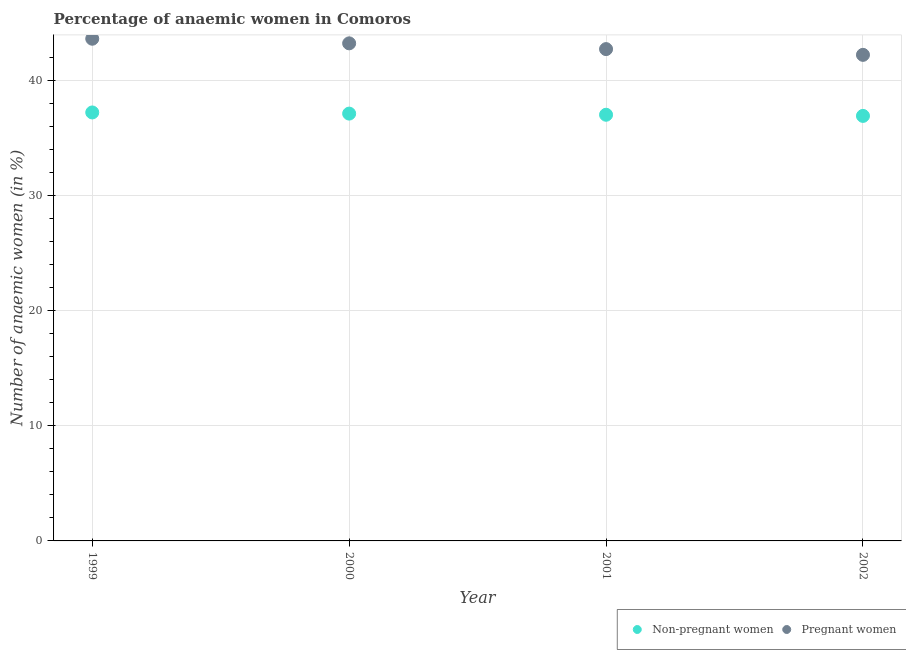How many different coloured dotlines are there?
Provide a succinct answer. 2. Is the number of dotlines equal to the number of legend labels?
Ensure brevity in your answer.  Yes. What is the percentage of non-pregnant anaemic women in 2000?
Offer a very short reply. 37.1. Across all years, what is the maximum percentage of non-pregnant anaemic women?
Ensure brevity in your answer.  37.2. Across all years, what is the minimum percentage of pregnant anaemic women?
Provide a short and direct response. 42.2. What is the total percentage of non-pregnant anaemic women in the graph?
Provide a short and direct response. 148.2. What is the difference between the percentage of non-pregnant anaemic women in 1999 and that in 2001?
Give a very brief answer. 0.2. What is the difference between the percentage of non-pregnant anaemic women in 2001 and the percentage of pregnant anaemic women in 2000?
Offer a terse response. -6.2. What is the average percentage of pregnant anaemic women per year?
Provide a short and direct response. 42.92. In the year 1999, what is the difference between the percentage of pregnant anaemic women and percentage of non-pregnant anaemic women?
Your response must be concise. 6.4. In how many years, is the percentage of pregnant anaemic women greater than 18 %?
Your answer should be compact. 4. What is the ratio of the percentage of pregnant anaemic women in 1999 to that in 2000?
Your response must be concise. 1.01. What is the difference between the highest and the second highest percentage of non-pregnant anaemic women?
Offer a very short reply. 0.1. What is the difference between the highest and the lowest percentage of non-pregnant anaemic women?
Your response must be concise. 0.3. In how many years, is the percentage of non-pregnant anaemic women greater than the average percentage of non-pregnant anaemic women taken over all years?
Ensure brevity in your answer.  2. Is the percentage of pregnant anaemic women strictly less than the percentage of non-pregnant anaemic women over the years?
Provide a succinct answer. No. What is the difference between two consecutive major ticks on the Y-axis?
Keep it short and to the point. 10. Does the graph contain any zero values?
Ensure brevity in your answer.  No. Where does the legend appear in the graph?
Keep it short and to the point. Bottom right. What is the title of the graph?
Your answer should be very brief. Percentage of anaemic women in Comoros. What is the label or title of the Y-axis?
Provide a short and direct response. Number of anaemic women (in %). What is the Number of anaemic women (in %) in Non-pregnant women in 1999?
Make the answer very short. 37.2. What is the Number of anaemic women (in %) of Pregnant women in 1999?
Ensure brevity in your answer.  43.6. What is the Number of anaemic women (in %) in Non-pregnant women in 2000?
Give a very brief answer. 37.1. What is the Number of anaemic women (in %) in Pregnant women in 2000?
Provide a short and direct response. 43.2. What is the Number of anaemic women (in %) in Non-pregnant women in 2001?
Provide a short and direct response. 37. What is the Number of anaemic women (in %) in Pregnant women in 2001?
Make the answer very short. 42.7. What is the Number of anaemic women (in %) of Non-pregnant women in 2002?
Your response must be concise. 36.9. What is the Number of anaemic women (in %) in Pregnant women in 2002?
Provide a short and direct response. 42.2. Across all years, what is the maximum Number of anaemic women (in %) in Non-pregnant women?
Make the answer very short. 37.2. Across all years, what is the maximum Number of anaemic women (in %) of Pregnant women?
Provide a succinct answer. 43.6. Across all years, what is the minimum Number of anaemic women (in %) of Non-pregnant women?
Ensure brevity in your answer.  36.9. Across all years, what is the minimum Number of anaemic women (in %) in Pregnant women?
Ensure brevity in your answer.  42.2. What is the total Number of anaemic women (in %) in Non-pregnant women in the graph?
Your answer should be very brief. 148.2. What is the total Number of anaemic women (in %) in Pregnant women in the graph?
Your response must be concise. 171.7. What is the difference between the Number of anaemic women (in %) of Non-pregnant women in 1999 and that in 2000?
Make the answer very short. 0.1. What is the difference between the Number of anaemic women (in %) of Non-pregnant women in 1999 and that in 2001?
Ensure brevity in your answer.  0.2. What is the difference between the Number of anaemic women (in %) in Pregnant women in 1999 and that in 2001?
Provide a succinct answer. 0.9. What is the difference between the Number of anaemic women (in %) in Non-pregnant women in 1999 and that in 2002?
Provide a succinct answer. 0.3. What is the difference between the Number of anaemic women (in %) of Pregnant women in 1999 and that in 2002?
Ensure brevity in your answer.  1.4. What is the difference between the Number of anaemic women (in %) in Non-pregnant women in 2000 and that in 2001?
Offer a very short reply. 0.1. What is the difference between the Number of anaemic women (in %) of Pregnant women in 2000 and that in 2001?
Give a very brief answer. 0.5. What is the difference between the Number of anaemic women (in %) in Non-pregnant women in 2001 and that in 2002?
Ensure brevity in your answer.  0.1. What is the difference between the Number of anaemic women (in %) in Pregnant women in 2001 and that in 2002?
Ensure brevity in your answer.  0.5. What is the difference between the Number of anaemic women (in %) in Non-pregnant women in 2001 and the Number of anaemic women (in %) in Pregnant women in 2002?
Keep it short and to the point. -5.2. What is the average Number of anaemic women (in %) of Non-pregnant women per year?
Offer a very short reply. 37.05. What is the average Number of anaemic women (in %) in Pregnant women per year?
Provide a succinct answer. 42.92. In the year 1999, what is the difference between the Number of anaemic women (in %) of Non-pregnant women and Number of anaemic women (in %) of Pregnant women?
Your answer should be very brief. -6.4. In the year 2000, what is the difference between the Number of anaemic women (in %) of Non-pregnant women and Number of anaemic women (in %) of Pregnant women?
Your answer should be compact. -6.1. In the year 2001, what is the difference between the Number of anaemic women (in %) of Non-pregnant women and Number of anaemic women (in %) of Pregnant women?
Ensure brevity in your answer.  -5.7. In the year 2002, what is the difference between the Number of anaemic women (in %) of Non-pregnant women and Number of anaemic women (in %) of Pregnant women?
Your answer should be compact. -5.3. What is the ratio of the Number of anaemic women (in %) of Pregnant women in 1999 to that in 2000?
Your answer should be very brief. 1.01. What is the ratio of the Number of anaemic women (in %) of Non-pregnant women in 1999 to that in 2001?
Ensure brevity in your answer.  1.01. What is the ratio of the Number of anaemic women (in %) of Pregnant women in 1999 to that in 2001?
Give a very brief answer. 1.02. What is the ratio of the Number of anaemic women (in %) of Pregnant women in 1999 to that in 2002?
Give a very brief answer. 1.03. What is the ratio of the Number of anaemic women (in %) of Non-pregnant women in 2000 to that in 2001?
Give a very brief answer. 1. What is the ratio of the Number of anaemic women (in %) of Pregnant women in 2000 to that in 2001?
Your answer should be very brief. 1.01. What is the ratio of the Number of anaemic women (in %) of Non-pregnant women in 2000 to that in 2002?
Ensure brevity in your answer.  1.01. What is the ratio of the Number of anaemic women (in %) in Pregnant women in 2000 to that in 2002?
Make the answer very short. 1.02. What is the ratio of the Number of anaemic women (in %) of Pregnant women in 2001 to that in 2002?
Your answer should be compact. 1.01. What is the difference between the highest and the lowest Number of anaemic women (in %) of Pregnant women?
Provide a short and direct response. 1.4. 